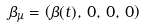Convert formula to latex. <formula><loc_0><loc_0><loc_500><loc_500>\beta _ { \mu } = \left ( \beta ( t ) , \, 0 , \, 0 , \, 0 \right )</formula> 